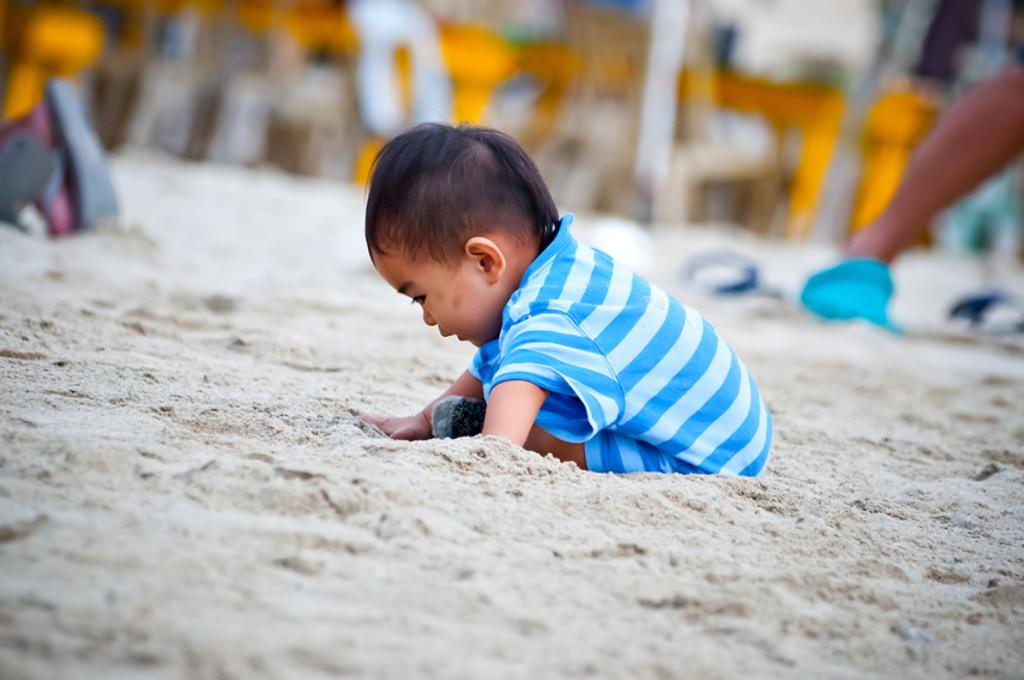What is the main subject of the picture? The main subject of the picture is a kid. Where is the kid located in the image? The kid is in the center of the picture. What is the kid doing in the image? The kid is playing in the sand. Can you describe the background of the image? The background of the image is blurred. What type of dress is the kid wearing in the wilderness? There is no mention of a dress or wilderness in the image. The kid is playing in the sand, and the background is blurred. 